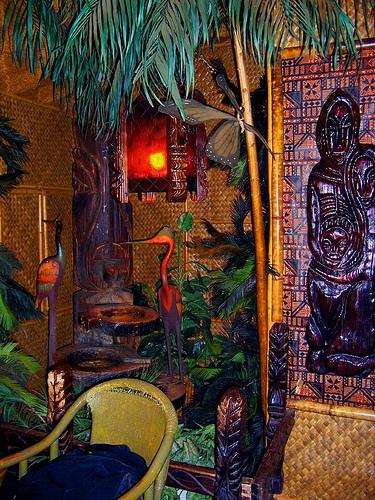Would there be a chair in the image if the chair was not in the picture? If the chair that's visible in the image wasn't there, there would be an empty space. Based on the layout, it seems the area is designed for seating, so without this chair, one might anticipate another form of seating or decorative element to fill the space, maintaining the room's aesthetic balance. 